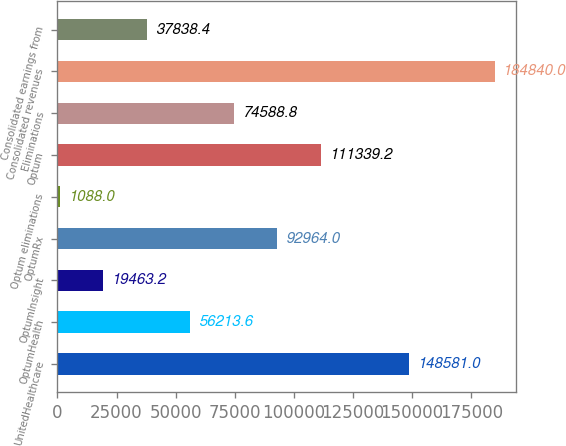Convert chart to OTSL. <chart><loc_0><loc_0><loc_500><loc_500><bar_chart><fcel>UnitedHealthcare<fcel>OptumHealth<fcel>OptumInsight<fcel>OptumRx<fcel>Optum eliminations<fcel>Optum<fcel>Eliminations<fcel>Consolidated revenues<fcel>Consolidated earnings from<nl><fcel>148581<fcel>56213.6<fcel>19463.2<fcel>92964<fcel>1088<fcel>111339<fcel>74588.8<fcel>184840<fcel>37838.4<nl></chart> 